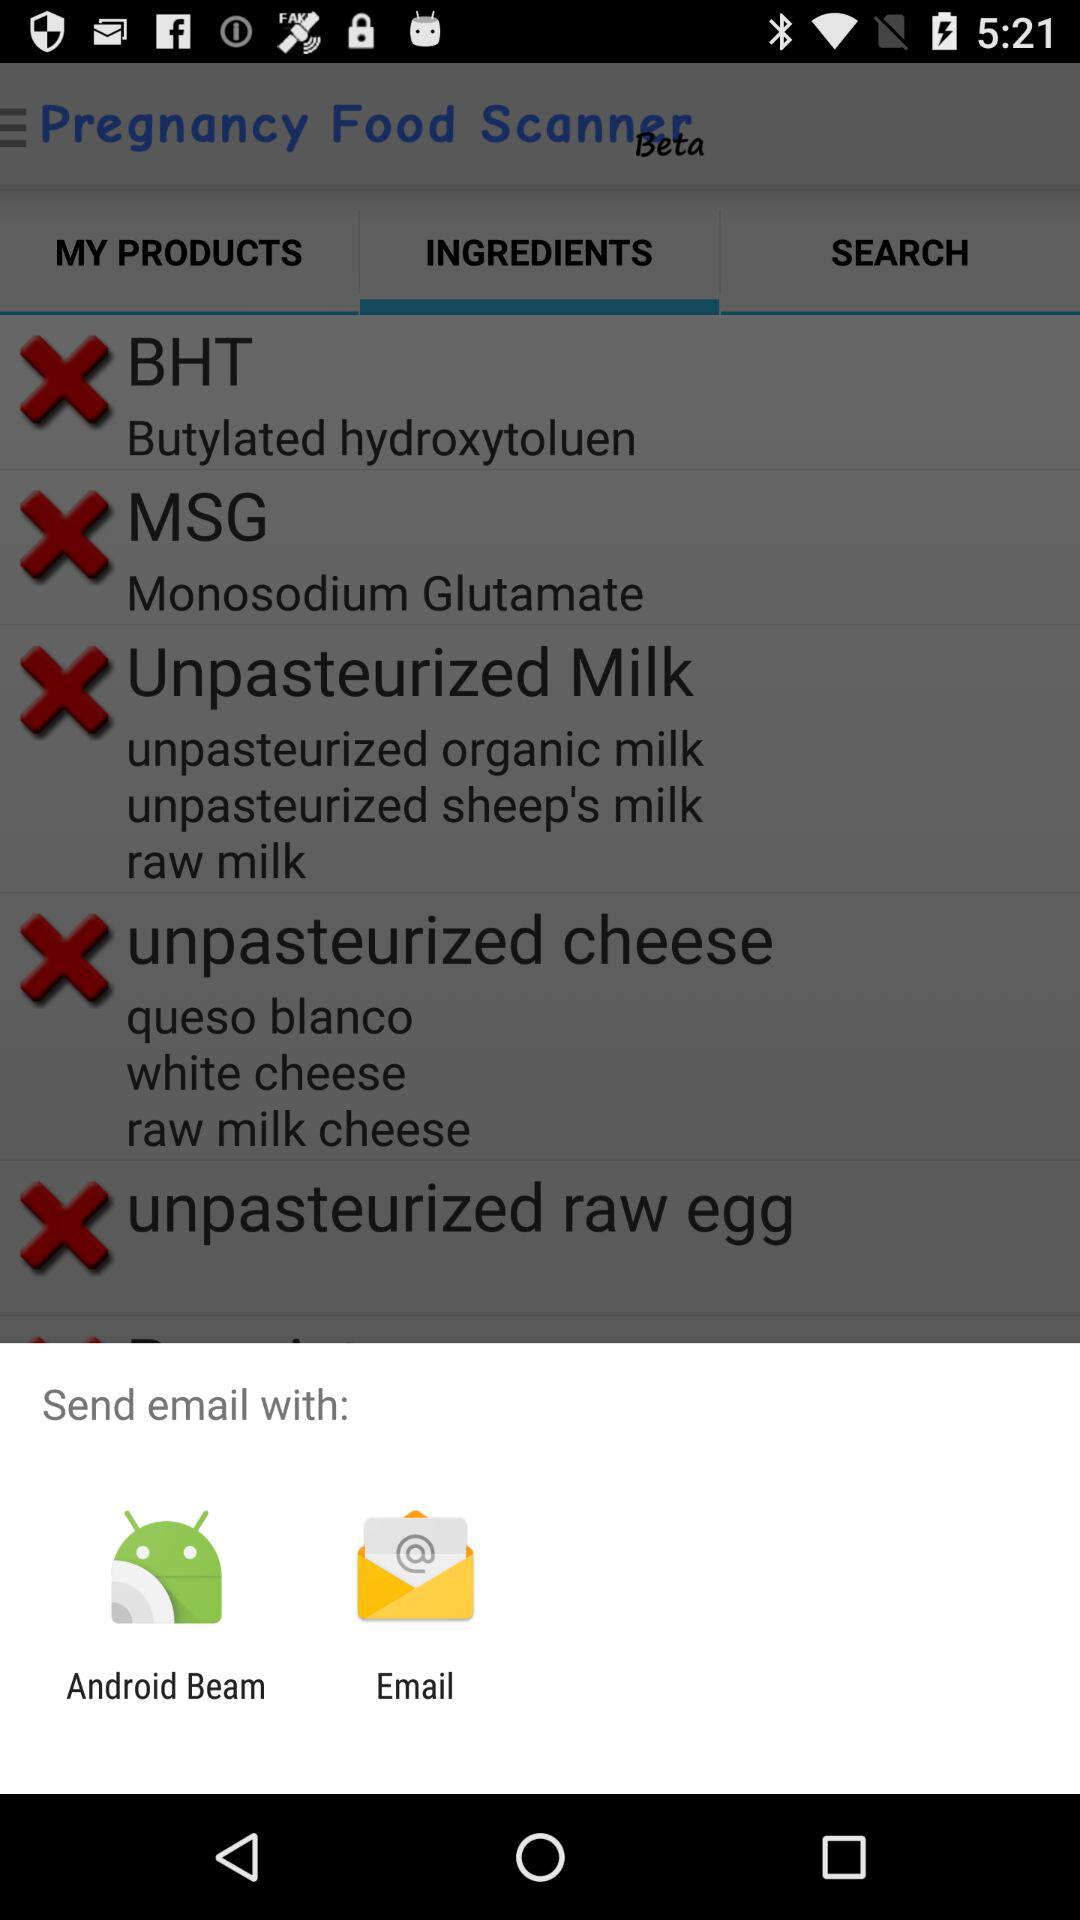How many of the ingredients are unpasteurized?
Answer the question using a single word or phrase. 3 